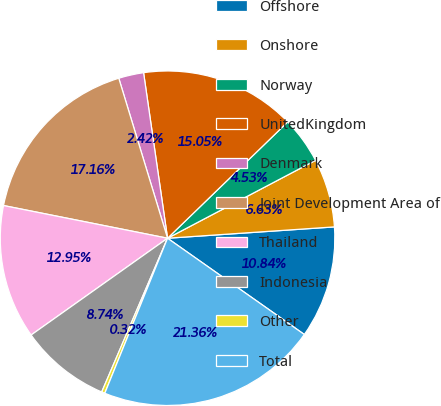<chart> <loc_0><loc_0><loc_500><loc_500><pie_chart><fcel>Offshore<fcel>Onshore<fcel>Norway<fcel>UnitedKingdom<fcel>Denmark<fcel>Joint Development Area of<fcel>Thailand<fcel>Indonesia<fcel>Other<fcel>Total<nl><fcel>10.84%<fcel>6.63%<fcel>4.53%<fcel>15.05%<fcel>2.42%<fcel>17.16%<fcel>12.95%<fcel>8.74%<fcel>0.32%<fcel>21.36%<nl></chart> 